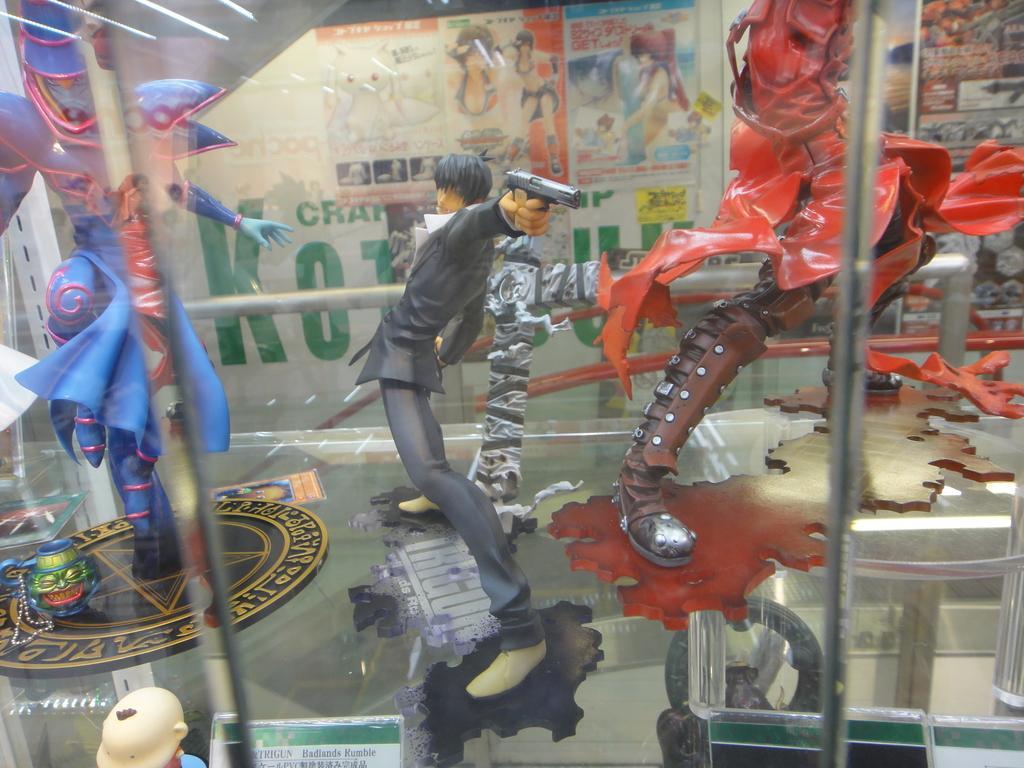In one or two sentences, can you explain what this image depicts? There are toys. In the background we can see posters. 